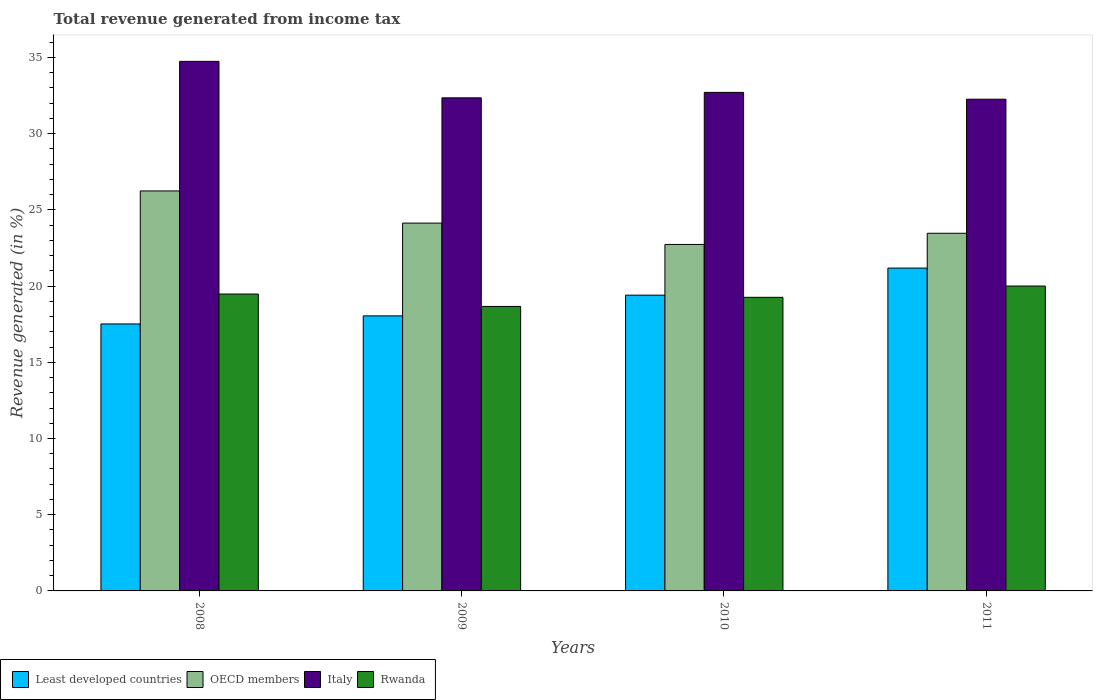How many different coloured bars are there?
Provide a succinct answer. 4. How many groups of bars are there?
Keep it short and to the point. 4. Are the number of bars on each tick of the X-axis equal?
Keep it short and to the point. Yes. How many bars are there on the 1st tick from the left?
Offer a very short reply. 4. How many bars are there on the 4th tick from the right?
Make the answer very short. 4. What is the label of the 2nd group of bars from the left?
Provide a succinct answer. 2009. In how many cases, is the number of bars for a given year not equal to the number of legend labels?
Your answer should be very brief. 0. What is the total revenue generated in Rwanda in 2011?
Your answer should be compact. 20. Across all years, what is the maximum total revenue generated in Rwanda?
Keep it short and to the point. 20. Across all years, what is the minimum total revenue generated in Italy?
Your answer should be compact. 32.26. What is the total total revenue generated in OECD members in the graph?
Your answer should be very brief. 96.57. What is the difference between the total revenue generated in OECD members in 2008 and that in 2010?
Offer a very short reply. 3.51. What is the difference between the total revenue generated in Italy in 2010 and the total revenue generated in Least developed countries in 2009?
Offer a very short reply. 14.66. What is the average total revenue generated in Rwanda per year?
Make the answer very short. 19.35. In the year 2010, what is the difference between the total revenue generated in OECD members and total revenue generated in Rwanda?
Provide a short and direct response. 3.47. What is the ratio of the total revenue generated in Least developed countries in 2009 to that in 2011?
Keep it short and to the point. 0.85. What is the difference between the highest and the second highest total revenue generated in Least developed countries?
Your response must be concise. 1.78. What is the difference between the highest and the lowest total revenue generated in Italy?
Provide a short and direct response. 2.48. Is it the case that in every year, the sum of the total revenue generated in Rwanda and total revenue generated in Italy is greater than the sum of total revenue generated in OECD members and total revenue generated in Least developed countries?
Your answer should be very brief. Yes. What does the 1st bar from the right in 2011 represents?
Your response must be concise. Rwanda. Are all the bars in the graph horizontal?
Make the answer very short. No. What is the difference between two consecutive major ticks on the Y-axis?
Your response must be concise. 5. Are the values on the major ticks of Y-axis written in scientific E-notation?
Keep it short and to the point. No. Does the graph contain any zero values?
Provide a succinct answer. No. How are the legend labels stacked?
Your response must be concise. Horizontal. What is the title of the graph?
Offer a terse response. Total revenue generated from income tax. What is the label or title of the Y-axis?
Ensure brevity in your answer.  Revenue generated (in %). What is the Revenue generated (in %) of Least developed countries in 2008?
Your answer should be compact. 17.52. What is the Revenue generated (in %) of OECD members in 2008?
Offer a terse response. 26.24. What is the Revenue generated (in %) of Italy in 2008?
Your response must be concise. 34.74. What is the Revenue generated (in %) of Rwanda in 2008?
Provide a succinct answer. 19.48. What is the Revenue generated (in %) of Least developed countries in 2009?
Your answer should be compact. 18.04. What is the Revenue generated (in %) of OECD members in 2009?
Provide a succinct answer. 24.13. What is the Revenue generated (in %) of Italy in 2009?
Offer a very short reply. 32.35. What is the Revenue generated (in %) in Rwanda in 2009?
Make the answer very short. 18.66. What is the Revenue generated (in %) in Least developed countries in 2010?
Offer a terse response. 19.4. What is the Revenue generated (in %) in OECD members in 2010?
Give a very brief answer. 22.73. What is the Revenue generated (in %) of Italy in 2010?
Your answer should be compact. 32.71. What is the Revenue generated (in %) in Rwanda in 2010?
Your answer should be compact. 19.26. What is the Revenue generated (in %) in Least developed countries in 2011?
Your answer should be very brief. 21.18. What is the Revenue generated (in %) of OECD members in 2011?
Give a very brief answer. 23.46. What is the Revenue generated (in %) in Italy in 2011?
Provide a short and direct response. 32.26. What is the Revenue generated (in %) of Rwanda in 2011?
Provide a succinct answer. 20. Across all years, what is the maximum Revenue generated (in %) in Least developed countries?
Provide a short and direct response. 21.18. Across all years, what is the maximum Revenue generated (in %) of OECD members?
Your answer should be compact. 26.24. Across all years, what is the maximum Revenue generated (in %) of Italy?
Keep it short and to the point. 34.74. Across all years, what is the maximum Revenue generated (in %) in Rwanda?
Offer a very short reply. 20. Across all years, what is the minimum Revenue generated (in %) in Least developed countries?
Ensure brevity in your answer.  17.52. Across all years, what is the minimum Revenue generated (in %) of OECD members?
Provide a short and direct response. 22.73. Across all years, what is the minimum Revenue generated (in %) in Italy?
Provide a short and direct response. 32.26. Across all years, what is the minimum Revenue generated (in %) of Rwanda?
Offer a terse response. 18.66. What is the total Revenue generated (in %) in Least developed countries in the graph?
Provide a succinct answer. 76.15. What is the total Revenue generated (in %) in OECD members in the graph?
Provide a short and direct response. 96.57. What is the total Revenue generated (in %) of Italy in the graph?
Offer a terse response. 132.06. What is the total Revenue generated (in %) in Rwanda in the graph?
Provide a short and direct response. 77.41. What is the difference between the Revenue generated (in %) in Least developed countries in 2008 and that in 2009?
Provide a succinct answer. -0.53. What is the difference between the Revenue generated (in %) in OECD members in 2008 and that in 2009?
Offer a terse response. 2.11. What is the difference between the Revenue generated (in %) in Italy in 2008 and that in 2009?
Your response must be concise. 2.39. What is the difference between the Revenue generated (in %) in Rwanda in 2008 and that in 2009?
Provide a short and direct response. 0.81. What is the difference between the Revenue generated (in %) in Least developed countries in 2008 and that in 2010?
Offer a very short reply. -1.89. What is the difference between the Revenue generated (in %) of OECD members in 2008 and that in 2010?
Ensure brevity in your answer.  3.51. What is the difference between the Revenue generated (in %) in Italy in 2008 and that in 2010?
Your answer should be very brief. 2.04. What is the difference between the Revenue generated (in %) of Rwanda in 2008 and that in 2010?
Provide a succinct answer. 0.22. What is the difference between the Revenue generated (in %) of Least developed countries in 2008 and that in 2011?
Your answer should be compact. -3.67. What is the difference between the Revenue generated (in %) of OECD members in 2008 and that in 2011?
Provide a short and direct response. 2.78. What is the difference between the Revenue generated (in %) of Italy in 2008 and that in 2011?
Your response must be concise. 2.48. What is the difference between the Revenue generated (in %) of Rwanda in 2008 and that in 2011?
Offer a terse response. -0.52. What is the difference between the Revenue generated (in %) in Least developed countries in 2009 and that in 2010?
Your response must be concise. -1.36. What is the difference between the Revenue generated (in %) of OECD members in 2009 and that in 2010?
Make the answer very short. 1.4. What is the difference between the Revenue generated (in %) of Italy in 2009 and that in 2010?
Offer a very short reply. -0.36. What is the difference between the Revenue generated (in %) in Rwanda in 2009 and that in 2010?
Offer a terse response. -0.6. What is the difference between the Revenue generated (in %) of Least developed countries in 2009 and that in 2011?
Give a very brief answer. -3.14. What is the difference between the Revenue generated (in %) in OECD members in 2009 and that in 2011?
Ensure brevity in your answer.  0.67. What is the difference between the Revenue generated (in %) of Italy in 2009 and that in 2011?
Your answer should be very brief. 0.09. What is the difference between the Revenue generated (in %) of Rwanda in 2009 and that in 2011?
Keep it short and to the point. -1.34. What is the difference between the Revenue generated (in %) in Least developed countries in 2010 and that in 2011?
Offer a terse response. -1.78. What is the difference between the Revenue generated (in %) in OECD members in 2010 and that in 2011?
Your answer should be compact. -0.73. What is the difference between the Revenue generated (in %) in Italy in 2010 and that in 2011?
Your response must be concise. 0.45. What is the difference between the Revenue generated (in %) in Rwanda in 2010 and that in 2011?
Your answer should be very brief. -0.74. What is the difference between the Revenue generated (in %) of Least developed countries in 2008 and the Revenue generated (in %) of OECD members in 2009?
Offer a terse response. -6.62. What is the difference between the Revenue generated (in %) of Least developed countries in 2008 and the Revenue generated (in %) of Italy in 2009?
Provide a succinct answer. -14.83. What is the difference between the Revenue generated (in %) in Least developed countries in 2008 and the Revenue generated (in %) in Rwanda in 2009?
Provide a short and direct response. -1.15. What is the difference between the Revenue generated (in %) in OECD members in 2008 and the Revenue generated (in %) in Italy in 2009?
Your answer should be very brief. -6.11. What is the difference between the Revenue generated (in %) of OECD members in 2008 and the Revenue generated (in %) of Rwanda in 2009?
Make the answer very short. 7.58. What is the difference between the Revenue generated (in %) of Italy in 2008 and the Revenue generated (in %) of Rwanda in 2009?
Offer a terse response. 16.08. What is the difference between the Revenue generated (in %) in Least developed countries in 2008 and the Revenue generated (in %) in OECD members in 2010?
Offer a very short reply. -5.22. What is the difference between the Revenue generated (in %) in Least developed countries in 2008 and the Revenue generated (in %) in Italy in 2010?
Provide a short and direct response. -15.19. What is the difference between the Revenue generated (in %) of Least developed countries in 2008 and the Revenue generated (in %) of Rwanda in 2010?
Offer a very short reply. -1.75. What is the difference between the Revenue generated (in %) in OECD members in 2008 and the Revenue generated (in %) in Italy in 2010?
Your answer should be compact. -6.46. What is the difference between the Revenue generated (in %) of OECD members in 2008 and the Revenue generated (in %) of Rwanda in 2010?
Make the answer very short. 6.98. What is the difference between the Revenue generated (in %) of Italy in 2008 and the Revenue generated (in %) of Rwanda in 2010?
Ensure brevity in your answer.  15.48. What is the difference between the Revenue generated (in %) in Least developed countries in 2008 and the Revenue generated (in %) in OECD members in 2011?
Offer a terse response. -5.95. What is the difference between the Revenue generated (in %) in Least developed countries in 2008 and the Revenue generated (in %) in Italy in 2011?
Offer a terse response. -14.74. What is the difference between the Revenue generated (in %) in Least developed countries in 2008 and the Revenue generated (in %) in Rwanda in 2011?
Ensure brevity in your answer.  -2.49. What is the difference between the Revenue generated (in %) of OECD members in 2008 and the Revenue generated (in %) of Italy in 2011?
Offer a terse response. -6.02. What is the difference between the Revenue generated (in %) of OECD members in 2008 and the Revenue generated (in %) of Rwanda in 2011?
Make the answer very short. 6.24. What is the difference between the Revenue generated (in %) in Italy in 2008 and the Revenue generated (in %) in Rwanda in 2011?
Keep it short and to the point. 14.74. What is the difference between the Revenue generated (in %) in Least developed countries in 2009 and the Revenue generated (in %) in OECD members in 2010?
Your answer should be compact. -4.69. What is the difference between the Revenue generated (in %) of Least developed countries in 2009 and the Revenue generated (in %) of Italy in 2010?
Your answer should be compact. -14.66. What is the difference between the Revenue generated (in %) in Least developed countries in 2009 and the Revenue generated (in %) in Rwanda in 2010?
Keep it short and to the point. -1.22. What is the difference between the Revenue generated (in %) in OECD members in 2009 and the Revenue generated (in %) in Italy in 2010?
Your response must be concise. -8.58. What is the difference between the Revenue generated (in %) of OECD members in 2009 and the Revenue generated (in %) of Rwanda in 2010?
Give a very brief answer. 4.87. What is the difference between the Revenue generated (in %) of Italy in 2009 and the Revenue generated (in %) of Rwanda in 2010?
Provide a short and direct response. 13.09. What is the difference between the Revenue generated (in %) in Least developed countries in 2009 and the Revenue generated (in %) in OECD members in 2011?
Make the answer very short. -5.42. What is the difference between the Revenue generated (in %) in Least developed countries in 2009 and the Revenue generated (in %) in Italy in 2011?
Your answer should be very brief. -14.21. What is the difference between the Revenue generated (in %) of Least developed countries in 2009 and the Revenue generated (in %) of Rwanda in 2011?
Provide a short and direct response. -1.96. What is the difference between the Revenue generated (in %) of OECD members in 2009 and the Revenue generated (in %) of Italy in 2011?
Offer a very short reply. -8.13. What is the difference between the Revenue generated (in %) of OECD members in 2009 and the Revenue generated (in %) of Rwanda in 2011?
Offer a very short reply. 4.13. What is the difference between the Revenue generated (in %) in Italy in 2009 and the Revenue generated (in %) in Rwanda in 2011?
Your response must be concise. 12.35. What is the difference between the Revenue generated (in %) in Least developed countries in 2010 and the Revenue generated (in %) in OECD members in 2011?
Provide a succinct answer. -4.06. What is the difference between the Revenue generated (in %) of Least developed countries in 2010 and the Revenue generated (in %) of Italy in 2011?
Make the answer very short. -12.85. What is the difference between the Revenue generated (in %) of Least developed countries in 2010 and the Revenue generated (in %) of Rwanda in 2011?
Provide a succinct answer. -0.6. What is the difference between the Revenue generated (in %) of OECD members in 2010 and the Revenue generated (in %) of Italy in 2011?
Keep it short and to the point. -9.53. What is the difference between the Revenue generated (in %) in OECD members in 2010 and the Revenue generated (in %) in Rwanda in 2011?
Offer a very short reply. 2.73. What is the difference between the Revenue generated (in %) in Italy in 2010 and the Revenue generated (in %) in Rwanda in 2011?
Your answer should be compact. 12.7. What is the average Revenue generated (in %) in Least developed countries per year?
Give a very brief answer. 19.04. What is the average Revenue generated (in %) in OECD members per year?
Offer a terse response. 24.14. What is the average Revenue generated (in %) in Italy per year?
Your answer should be very brief. 33.01. What is the average Revenue generated (in %) in Rwanda per year?
Your response must be concise. 19.35. In the year 2008, what is the difference between the Revenue generated (in %) in Least developed countries and Revenue generated (in %) in OECD members?
Offer a terse response. -8.73. In the year 2008, what is the difference between the Revenue generated (in %) in Least developed countries and Revenue generated (in %) in Italy?
Give a very brief answer. -17.23. In the year 2008, what is the difference between the Revenue generated (in %) in Least developed countries and Revenue generated (in %) in Rwanda?
Make the answer very short. -1.96. In the year 2008, what is the difference between the Revenue generated (in %) of OECD members and Revenue generated (in %) of Italy?
Offer a terse response. -8.5. In the year 2008, what is the difference between the Revenue generated (in %) in OECD members and Revenue generated (in %) in Rwanda?
Provide a succinct answer. 6.76. In the year 2008, what is the difference between the Revenue generated (in %) in Italy and Revenue generated (in %) in Rwanda?
Offer a terse response. 15.27. In the year 2009, what is the difference between the Revenue generated (in %) in Least developed countries and Revenue generated (in %) in OECD members?
Your response must be concise. -6.09. In the year 2009, what is the difference between the Revenue generated (in %) in Least developed countries and Revenue generated (in %) in Italy?
Provide a succinct answer. -14.3. In the year 2009, what is the difference between the Revenue generated (in %) in Least developed countries and Revenue generated (in %) in Rwanda?
Keep it short and to the point. -0.62. In the year 2009, what is the difference between the Revenue generated (in %) of OECD members and Revenue generated (in %) of Italy?
Give a very brief answer. -8.22. In the year 2009, what is the difference between the Revenue generated (in %) of OECD members and Revenue generated (in %) of Rwanda?
Offer a terse response. 5.47. In the year 2009, what is the difference between the Revenue generated (in %) of Italy and Revenue generated (in %) of Rwanda?
Provide a short and direct response. 13.68. In the year 2010, what is the difference between the Revenue generated (in %) of Least developed countries and Revenue generated (in %) of OECD members?
Your answer should be compact. -3.33. In the year 2010, what is the difference between the Revenue generated (in %) in Least developed countries and Revenue generated (in %) in Italy?
Ensure brevity in your answer.  -13.3. In the year 2010, what is the difference between the Revenue generated (in %) in Least developed countries and Revenue generated (in %) in Rwanda?
Give a very brief answer. 0.14. In the year 2010, what is the difference between the Revenue generated (in %) in OECD members and Revenue generated (in %) in Italy?
Your response must be concise. -9.98. In the year 2010, what is the difference between the Revenue generated (in %) in OECD members and Revenue generated (in %) in Rwanda?
Your answer should be very brief. 3.47. In the year 2010, what is the difference between the Revenue generated (in %) of Italy and Revenue generated (in %) of Rwanda?
Your answer should be very brief. 13.44. In the year 2011, what is the difference between the Revenue generated (in %) of Least developed countries and Revenue generated (in %) of OECD members?
Provide a short and direct response. -2.28. In the year 2011, what is the difference between the Revenue generated (in %) of Least developed countries and Revenue generated (in %) of Italy?
Give a very brief answer. -11.08. In the year 2011, what is the difference between the Revenue generated (in %) of Least developed countries and Revenue generated (in %) of Rwanda?
Keep it short and to the point. 1.18. In the year 2011, what is the difference between the Revenue generated (in %) in OECD members and Revenue generated (in %) in Italy?
Your response must be concise. -8.8. In the year 2011, what is the difference between the Revenue generated (in %) of OECD members and Revenue generated (in %) of Rwanda?
Offer a terse response. 3.46. In the year 2011, what is the difference between the Revenue generated (in %) of Italy and Revenue generated (in %) of Rwanda?
Give a very brief answer. 12.26. What is the ratio of the Revenue generated (in %) of Least developed countries in 2008 to that in 2009?
Your response must be concise. 0.97. What is the ratio of the Revenue generated (in %) of OECD members in 2008 to that in 2009?
Your answer should be compact. 1.09. What is the ratio of the Revenue generated (in %) of Italy in 2008 to that in 2009?
Your answer should be compact. 1.07. What is the ratio of the Revenue generated (in %) of Rwanda in 2008 to that in 2009?
Offer a very short reply. 1.04. What is the ratio of the Revenue generated (in %) in Least developed countries in 2008 to that in 2010?
Give a very brief answer. 0.9. What is the ratio of the Revenue generated (in %) in OECD members in 2008 to that in 2010?
Give a very brief answer. 1.15. What is the ratio of the Revenue generated (in %) in Italy in 2008 to that in 2010?
Ensure brevity in your answer.  1.06. What is the ratio of the Revenue generated (in %) of Rwanda in 2008 to that in 2010?
Provide a succinct answer. 1.01. What is the ratio of the Revenue generated (in %) in Least developed countries in 2008 to that in 2011?
Offer a very short reply. 0.83. What is the ratio of the Revenue generated (in %) of OECD members in 2008 to that in 2011?
Ensure brevity in your answer.  1.12. What is the ratio of the Revenue generated (in %) of Italy in 2008 to that in 2011?
Give a very brief answer. 1.08. What is the ratio of the Revenue generated (in %) of Rwanda in 2008 to that in 2011?
Provide a short and direct response. 0.97. What is the ratio of the Revenue generated (in %) of Least developed countries in 2009 to that in 2010?
Offer a terse response. 0.93. What is the ratio of the Revenue generated (in %) of OECD members in 2009 to that in 2010?
Keep it short and to the point. 1.06. What is the ratio of the Revenue generated (in %) in Italy in 2009 to that in 2010?
Offer a terse response. 0.99. What is the ratio of the Revenue generated (in %) of Least developed countries in 2009 to that in 2011?
Provide a succinct answer. 0.85. What is the ratio of the Revenue generated (in %) in OECD members in 2009 to that in 2011?
Your answer should be very brief. 1.03. What is the ratio of the Revenue generated (in %) in Italy in 2009 to that in 2011?
Provide a succinct answer. 1. What is the ratio of the Revenue generated (in %) of Rwanda in 2009 to that in 2011?
Offer a very short reply. 0.93. What is the ratio of the Revenue generated (in %) of Least developed countries in 2010 to that in 2011?
Your answer should be very brief. 0.92. What is the ratio of the Revenue generated (in %) in OECD members in 2010 to that in 2011?
Ensure brevity in your answer.  0.97. What is the ratio of the Revenue generated (in %) of Italy in 2010 to that in 2011?
Offer a very short reply. 1.01. What is the ratio of the Revenue generated (in %) in Rwanda in 2010 to that in 2011?
Offer a terse response. 0.96. What is the difference between the highest and the second highest Revenue generated (in %) of Least developed countries?
Your response must be concise. 1.78. What is the difference between the highest and the second highest Revenue generated (in %) of OECD members?
Offer a very short reply. 2.11. What is the difference between the highest and the second highest Revenue generated (in %) of Italy?
Provide a short and direct response. 2.04. What is the difference between the highest and the second highest Revenue generated (in %) of Rwanda?
Ensure brevity in your answer.  0.52. What is the difference between the highest and the lowest Revenue generated (in %) of Least developed countries?
Offer a very short reply. 3.67. What is the difference between the highest and the lowest Revenue generated (in %) of OECD members?
Ensure brevity in your answer.  3.51. What is the difference between the highest and the lowest Revenue generated (in %) in Italy?
Give a very brief answer. 2.48. What is the difference between the highest and the lowest Revenue generated (in %) of Rwanda?
Your answer should be compact. 1.34. 